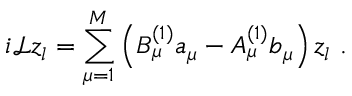Convert formula to latex. <formula><loc_0><loc_0><loc_500><loc_500>i \mathcal { L } z _ { l } = \sum _ { \mu = 1 } ^ { M } \left ( B _ { \mu } ^ { ( 1 ) } a _ { \mu } - A _ { \mu } ^ { ( 1 ) } b _ { \mu } \right ) z _ { l } .</formula> 